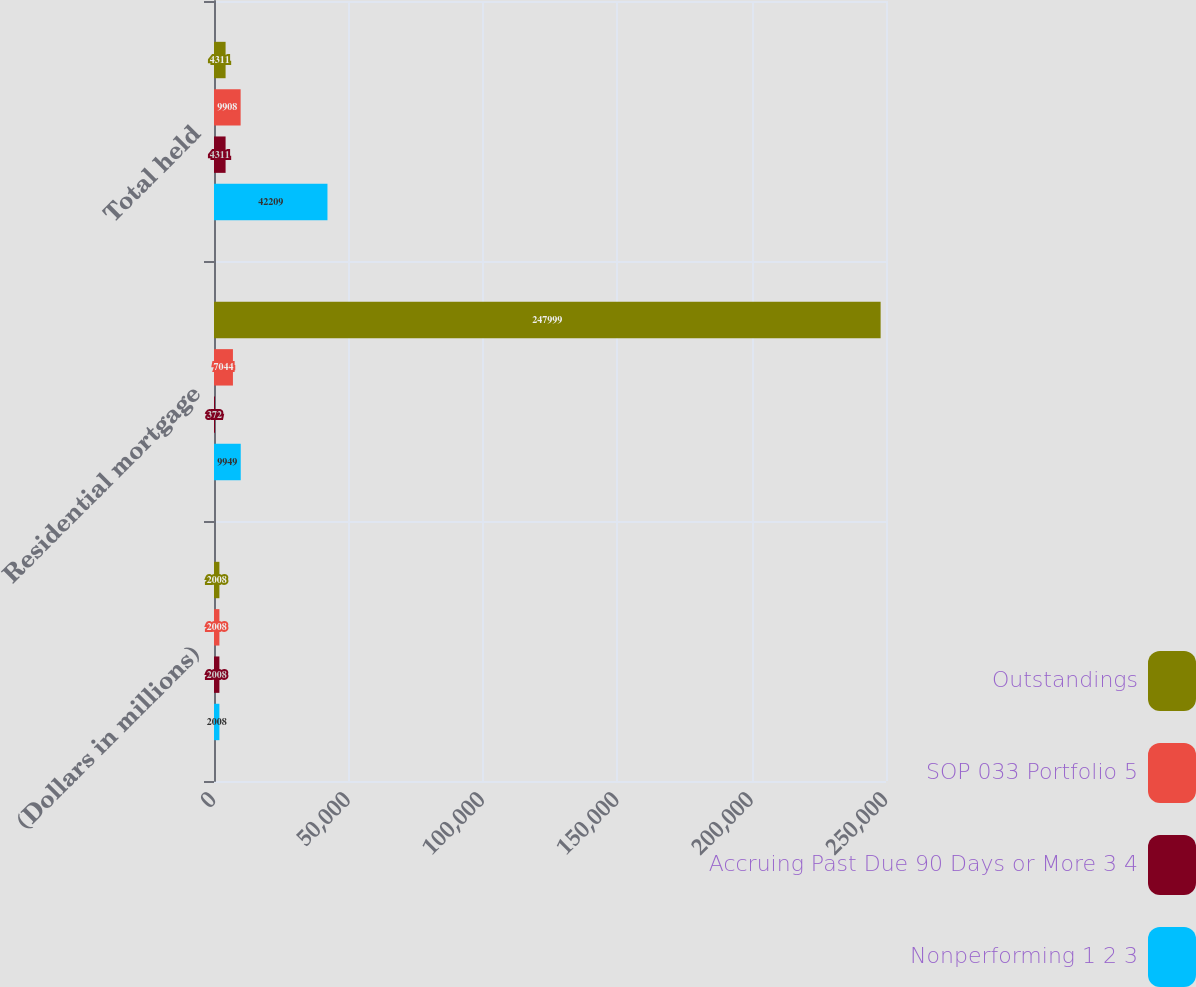<chart> <loc_0><loc_0><loc_500><loc_500><stacked_bar_chart><ecel><fcel>(Dollars in millions)<fcel>Residential mortgage<fcel>Total held<nl><fcel>Outstandings<fcel>2008<fcel>247999<fcel>4311<nl><fcel>SOP 033 Portfolio 5<fcel>2008<fcel>7044<fcel>9908<nl><fcel>Accruing Past Due 90 Days or More 3 4<fcel>2008<fcel>372<fcel>4311<nl><fcel>Nonperforming 1 2 3<fcel>2008<fcel>9949<fcel>42209<nl></chart> 